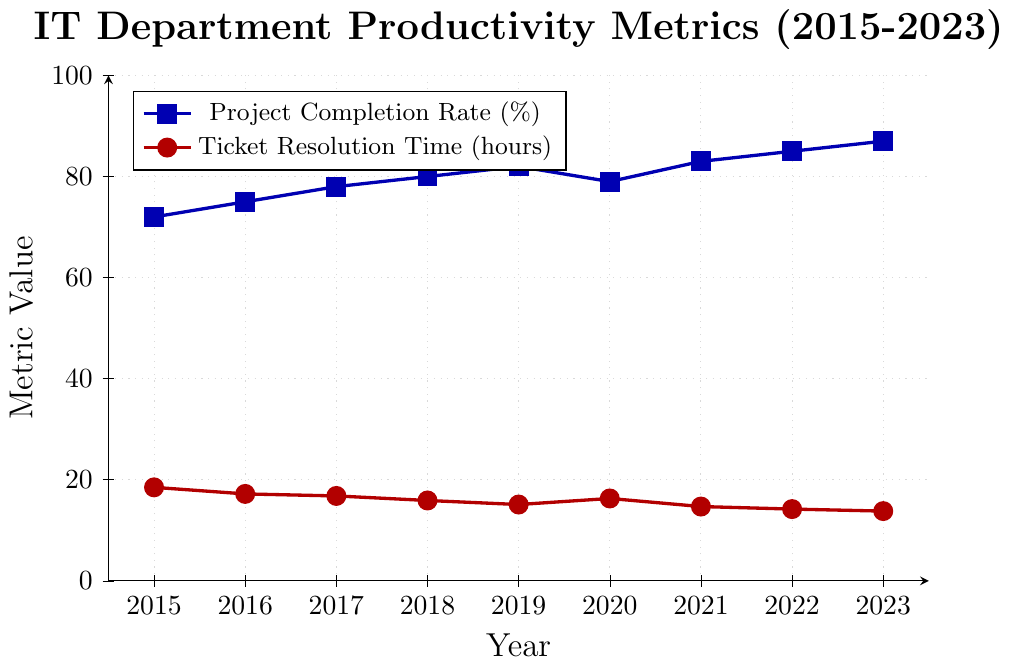What's the project completion rate in 2023? Locate the data point under "Project Completion Rate (\%)" for the year 2023.
Answer: 87% How does the ticket resolution time in 2023 compare to 2020? Find the values under "Ticket Resolution Time (hours)" for 2023 and 2020, then compare them. In 2023, it's 13.8 hours, and in 2020, it's 16.3 hours. 13.8 is less than 16.3.
Answer: 13.8 hours is less than 16.3 hours What is the difference in project completion rates between 2020 and 2019? The project completion rate in 2020 is 79% and in 2019 it is 82%. Subtract 79% from 82%.
Answer: 3% What is the trend of ticket resolution time from 2015 to 2023? Observe the red line indicating "Ticket Resolution Time (hours)." It shows a general decrease, dropping from 18.5 hours in 2015 to 13.8 hours in 2023.
Answer: Decreasing What's the average project completion rate from 2015 to 2023? Add the project completion rates from 2015 to 2023: (72 + 75 + 78 + 80 + 82 + 79 + 83 + 85 + 87) = 721. Divide the sum by the number of years, which is 9. 721 / 9
Answer: 80.1% Which year had the highest ticket resolution time? The highest point on the red "Ticket Resolution Time (hours)" line is 18.5 in 2015.
Answer: 2015 By how much did the project completion rate increase from 2017 to 2023? Project completion rate in 2017 is 78% and in 2023 is 87%. Subtract 78% from 87%.
Answer: 9% How has the relationship between project completion rate and ticket resolution time evolved? Observe both lines. Project completion rate (blue) has generally increased, while ticket resolution time (red) has generally decreased over the years from 2015 to 2023.
Answer: Increased completion rate and decreased resolution time Which metric showed greater variation over the years, project completion rate or ticket resolution time? Compare the range of values for both metrics. Project completion rate ranges from 72% to 87% (15% variation) and ticket resolution time from 18.5 to 13.8 (4.7 hours variation).
Answer: Ticket resolution time What can you infer about IT department efficiency from 2015 to 2023? Project completion rates increased and ticket resolution times decreased, indicating improved efficiency.
Answer: Improved efficiency 